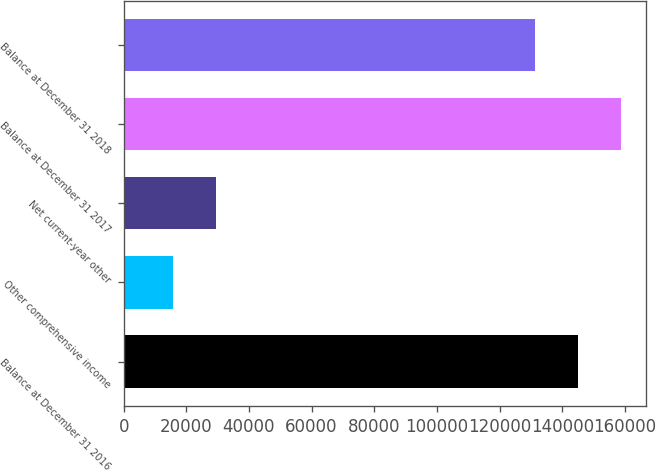<chart> <loc_0><loc_0><loc_500><loc_500><bar_chart><fcel>Balance at December 31 2016<fcel>Other comprehensive income<fcel>Net current-year other<fcel>Balance at December 31 2017<fcel>Balance at December 31 2018<nl><fcel>145040<fcel>15871.6<fcel>29531.2<fcel>158699<fcel>131380<nl></chart> 